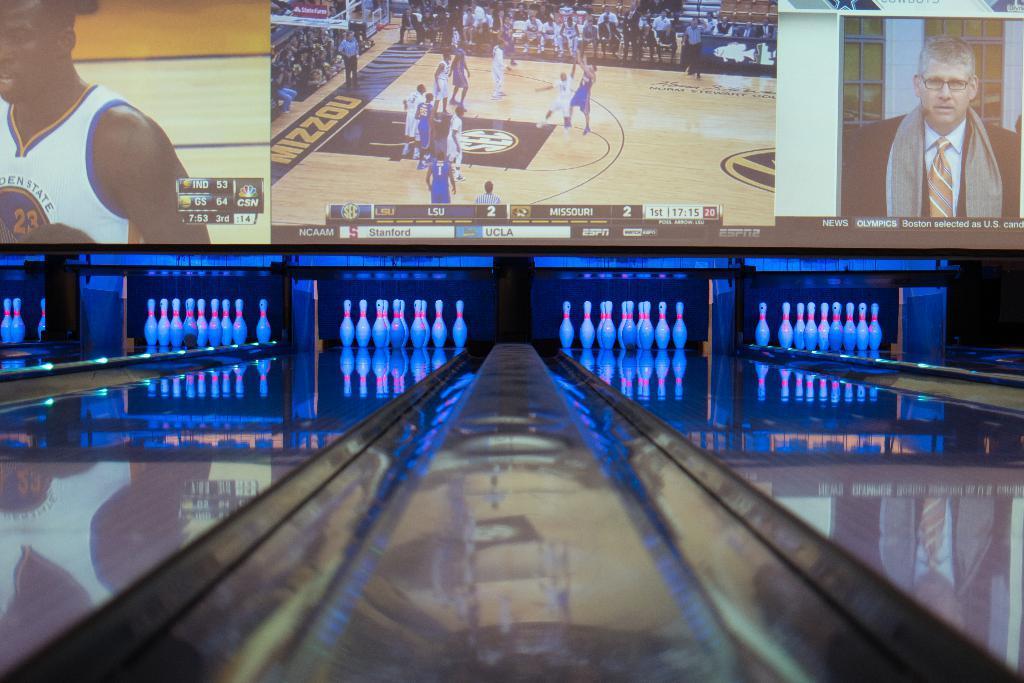In one or two sentences, can you explain what this image depicts? In this image there is a ten pin bowling game, in the background there is a screen, on that screen there are some pictures. 